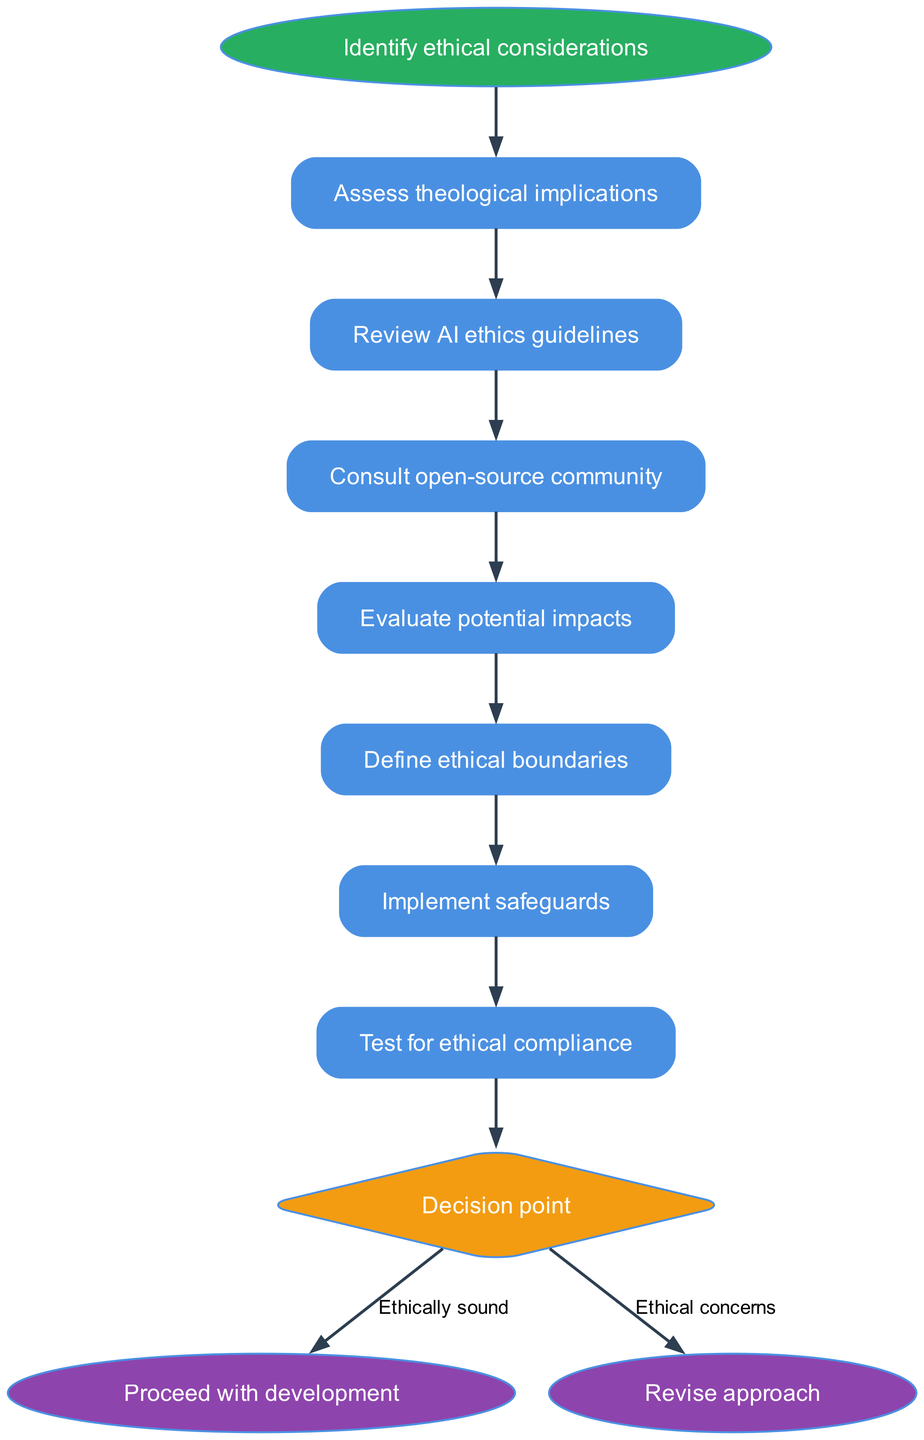What is the first step in the diagram? The first step is "Assess theological implications," which is the first listed step in the flow chart immediately after the start node.
Answer: Assess theological implications How many steps are there in total before reaching the decision point? The diagram lists 6 distinct steps prior to the decision point, which are assessed sequentially before arriving at the decision.
Answer: 6 What follows after "Test for ethical compliance"? The node "Test for ethical compliance" is followed by the decision point, which is the next logical step in the flow chart.
Answer: Decision point What are the two options at the decision point? The decision point has two options: "Ethically sound" and "Ethical concerns," which are the possible outcomes of the evaluation process.
Answer: Ethically sound, Ethical concerns If the outcome is "Ethically sound," what is the next step? If the decision at the decision point is "Ethically sound," the next step is to "Proceed with development," which is directly linked to that outcome.
Answer: Proceed with development What is the node shape used for the decision point? The decision point is represented by a diamond shape in the flow chart, which is characteristic of decision nodes in flow diagrams.
Answer: Diamond How does the flow start according to the diagram? The flow starts with the node labeled "Identify ethical considerations," which connects to the first step in the process.
Answer: Identify ethical considerations What would happen if "Ethical concerns" is chosen at the decision point? If "Ethical concerns" is chosen at the decision point, the next step indicated is to "Revise approach," which is the necessary response to address those concerns.
Answer: Revise approach 